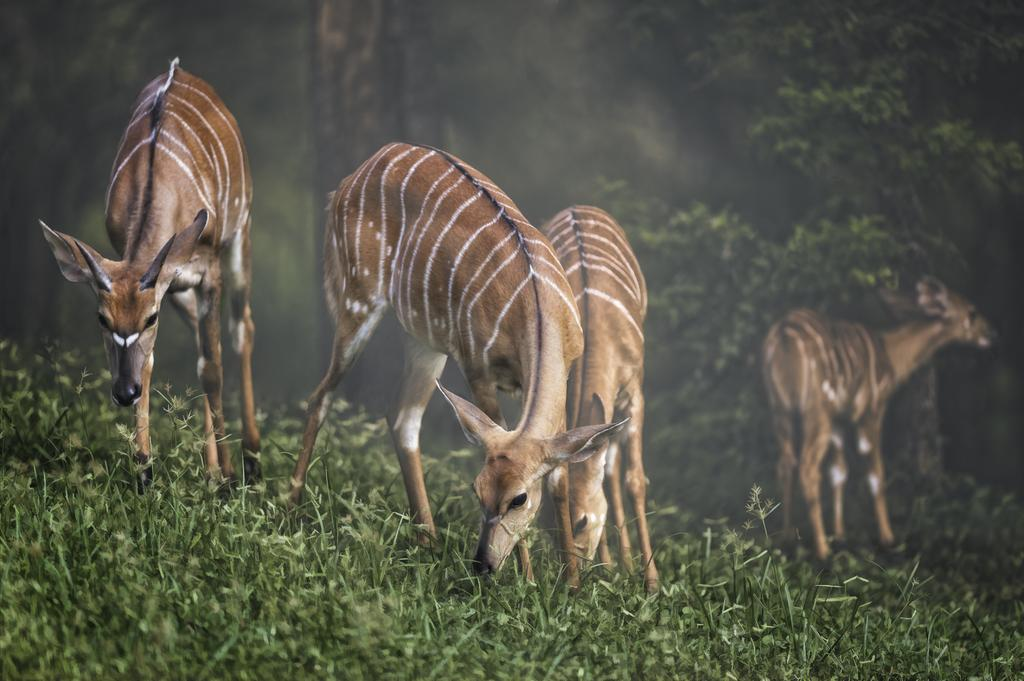How many deer are present in the image? There are four deer in the image. What is the terrain on which the deer are standing? The deer are on grass. Are there any other natural elements visible in the image? Yes, there are trees in the image. Can you describe the lighting conditions in the image? The image may have been taken during the night, as it appears to be dark. What type of root can be seen growing near the deer in the image? There is no root visible in the image; it only features deer, grass, and trees. 